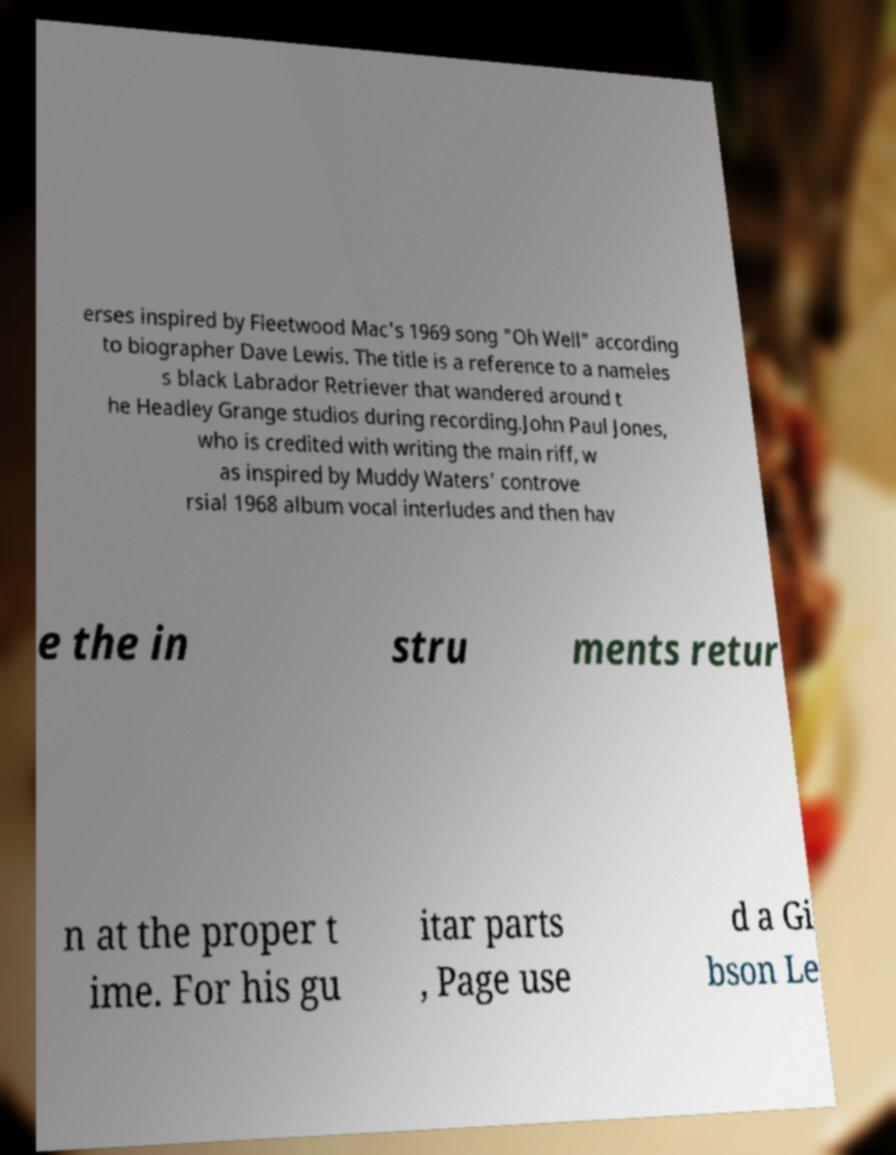Could you extract and type out the text from this image? erses inspired by Fleetwood Mac's 1969 song "Oh Well" according to biographer Dave Lewis. The title is a reference to a nameles s black Labrador Retriever that wandered around t he Headley Grange studios during recording.John Paul Jones, who is credited with writing the main riff, w as inspired by Muddy Waters' controve rsial 1968 album vocal interludes and then hav e the in stru ments retur n at the proper t ime. For his gu itar parts , Page use d a Gi bson Le 